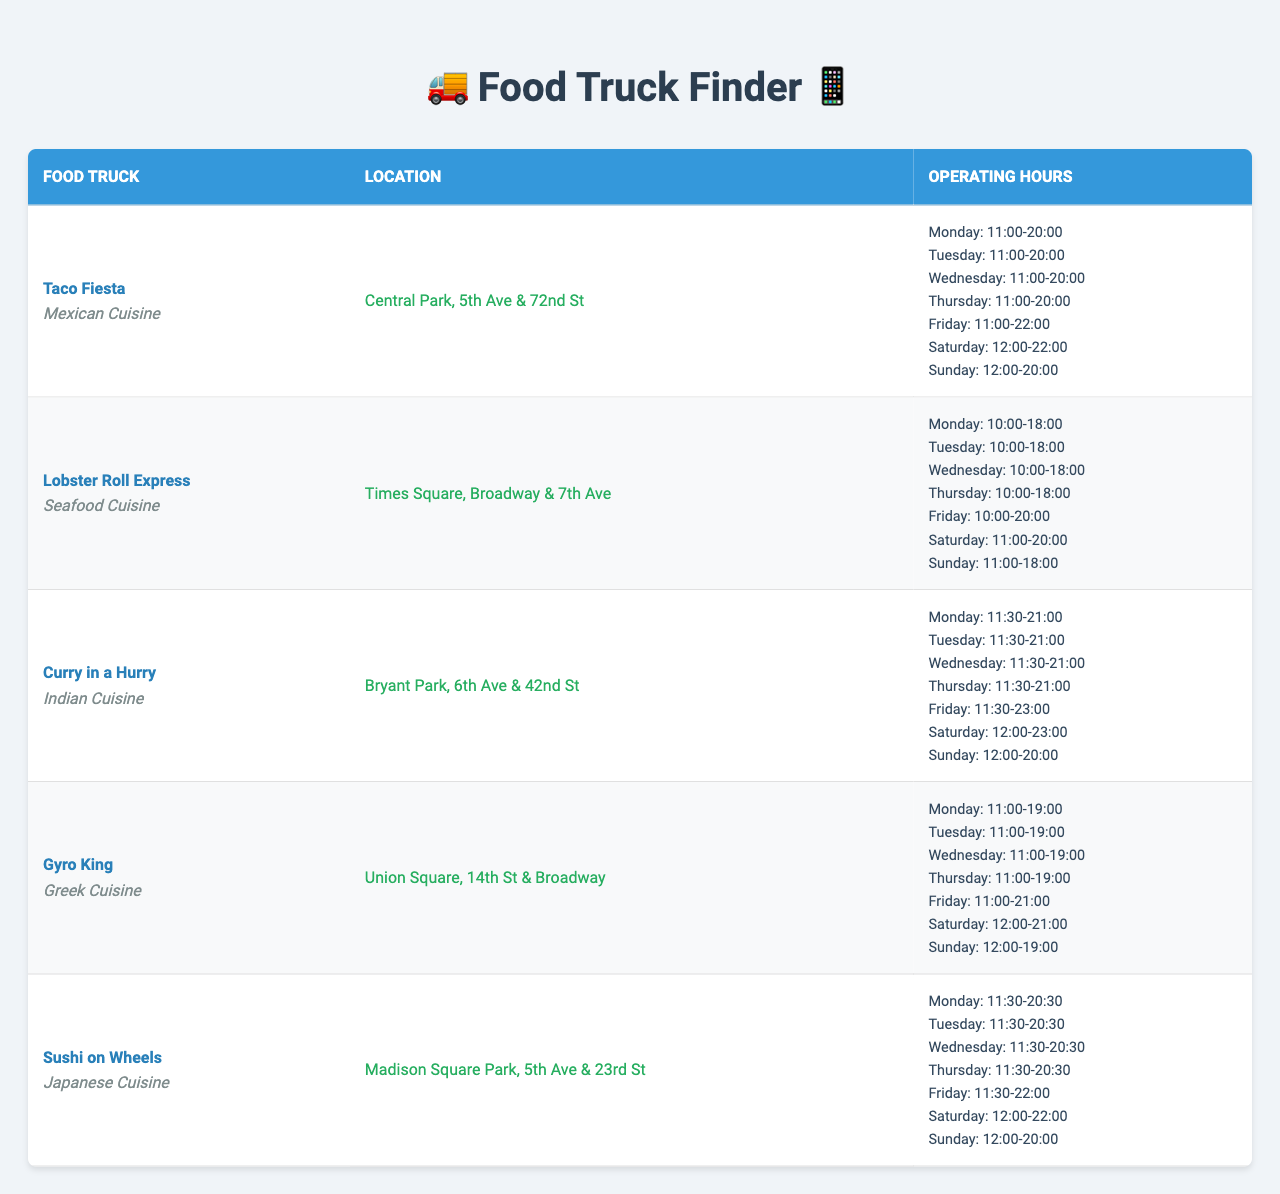What are the operating hours of Taco Fiesta on Friday? The table lists the operating hours of each food truck by day. For Taco Fiesta under Friday, it shows that the operating hours are from 11:00 to 22:00.
Answer: 11:00-22:00 Which food truck serves Japanese cuisine? By reviewing the table, I can see that Sushi on Wheels is the only food truck categorized under Japanese cuisine.
Answer: Sushi on Wheels How many food trucks operate on Sunday until 20:00? I need to check the operating hours for each food truck on Sunday. Taco Fiesta, Curry in a Hurry, Sushi on Wheels, and Gyro King all operate until 20:00, so there are four trucks in total.
Answer: 4 What is the total number of hours Taco Fiesta is open from Monday to Friday? First, I'll determine Taco Fiesta's operating hours for each applicable day: Monday to Thursday is 9 hours each (11:00-20:00), Friday is 11 hours (11:00-22:00). Calculating: (9 + 9 + 9 + 9 + 11) = 47 hours.
Answer: 47 Which food truck has the longest operating hours on Saturday? I will compare the Saturday hours of each food truck. Curry in a Hurry and Sushi on Wheels both operate until 23:00, which is later than the others. I conclude that both of these trucks have the longest hours on that day.
Answer: Curry in a Hurry and Sushi on Wheels True or False: Lobster Roll Express is open later than Gyro King on any day. I will check the operating hours for both food trucks for each day. From the comparison, Lobster Roll Express is open until 20:00 on Friday, while Gyro King closes at 21:00. Therefore, the statement is false.
Answer: False If you are at Bryant Park on a Wednesday, what time can you order from Curry in a Hurry? The table indicates that Curry in a Hurry is open on Wednesdays from 11:30 to 21:00, allowing me to order at any time during this window.
Answer: 11:30-21:00 What day does the food truck Sushi on Wheels have the same closing time as Lobster Roll Express? I will check the closing hours for both food trucks on each day. On Saturday, both are open until 20:00. Hence, they share the same closing time.
Answer: Saturday What is the average opening time of all food trucks on Tuesday? To find the average opening time, I will convert each opening time to military format: Taco Fiesta (11:00), Lobster Roll Express (10:00), Curry in a Hurry (11:30), Gyro King (11:00), and Sushi on Wheels (11:30). Calculating the average: (11:00 + 10:00 + 11:30 + 11:00 + 11:30) gives an average open time of roughly 11:06 AM.
Answer: 11:06 Which cuisine is most frequently represented among the food trucks? Reviewing the cuisine types listed in the table, I see: Mexican (1), Seafood (1), Indian (1), Greek (1), and Japanese (1). Each cuisine is represented once, indicating there is no dominant cuisine type among the trucks.
Answer: No dominant cuisine type 